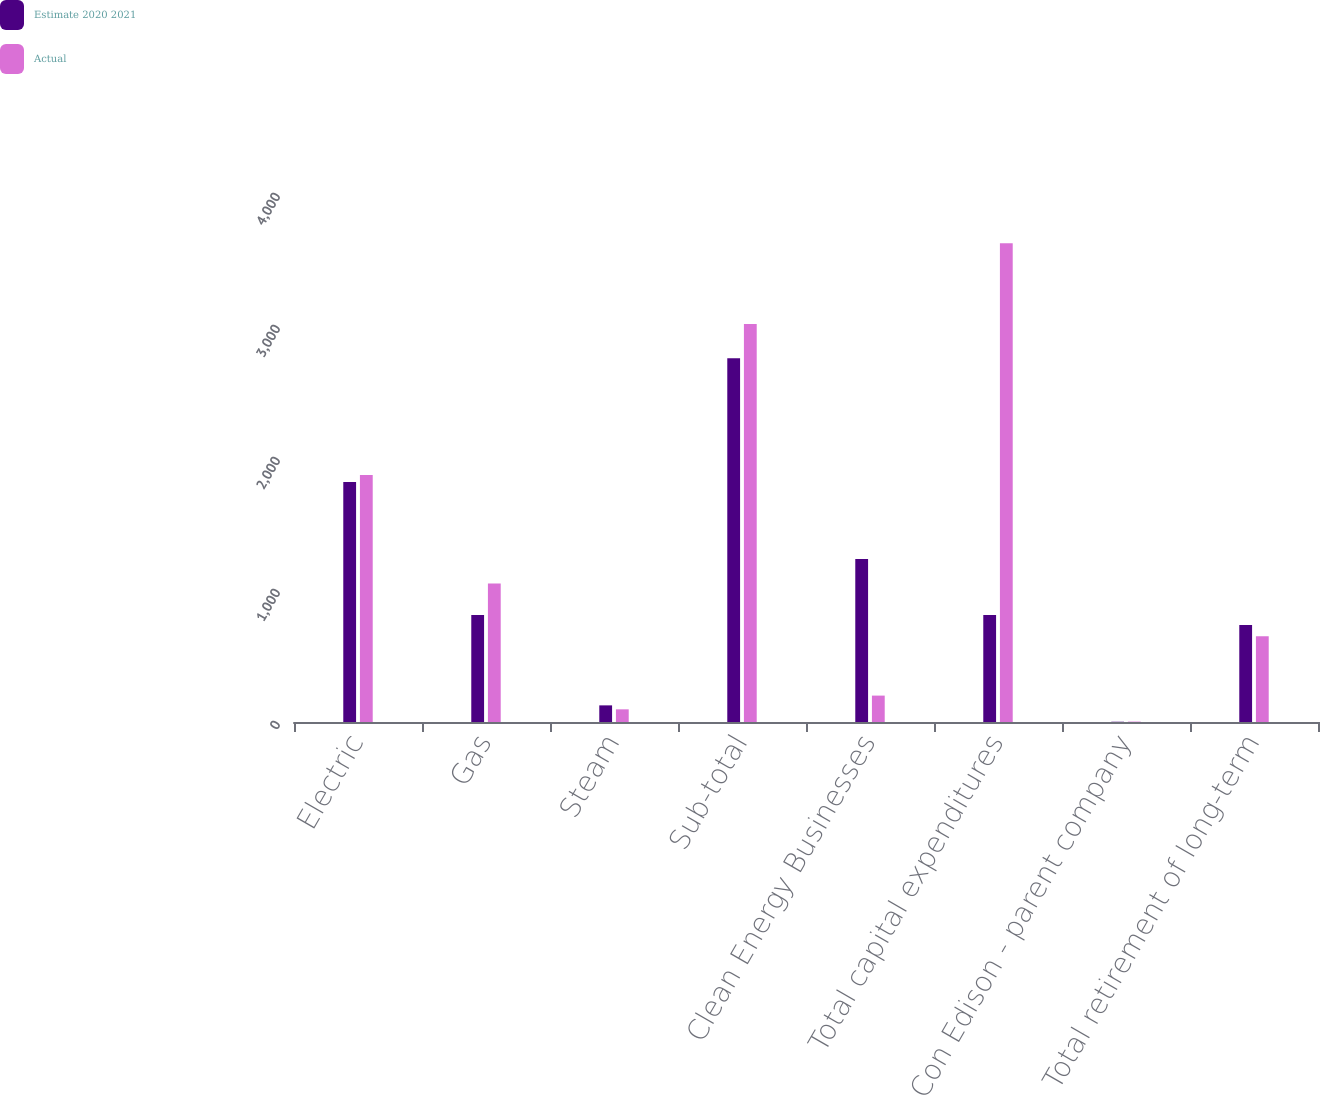<chart> <loc_0><loc_0><loc_500><loc_500><stacked_bar_chart><ecel><fcel>Electric<fcel>Gas<fcel>Steam<fcel>Sub-total<fcel>Clean Energy Businesses<fcel>Total capital expenditures<fcel>Con Edison - parent company<fcel>Total retirement of long-term<nl><fcel>Estimate 2020 2021<fcel>1819<fcel>811<fcel>126<fcel>2756<fcel>1235<fcel>811<fcel>2<fcel>735<nl><fcel>Actual<fcel>1871<fcel>1049<fcel>96<fcel>3016<fcel>200<fcel>3627<fcel>3<fcel>650<nl></chart> 